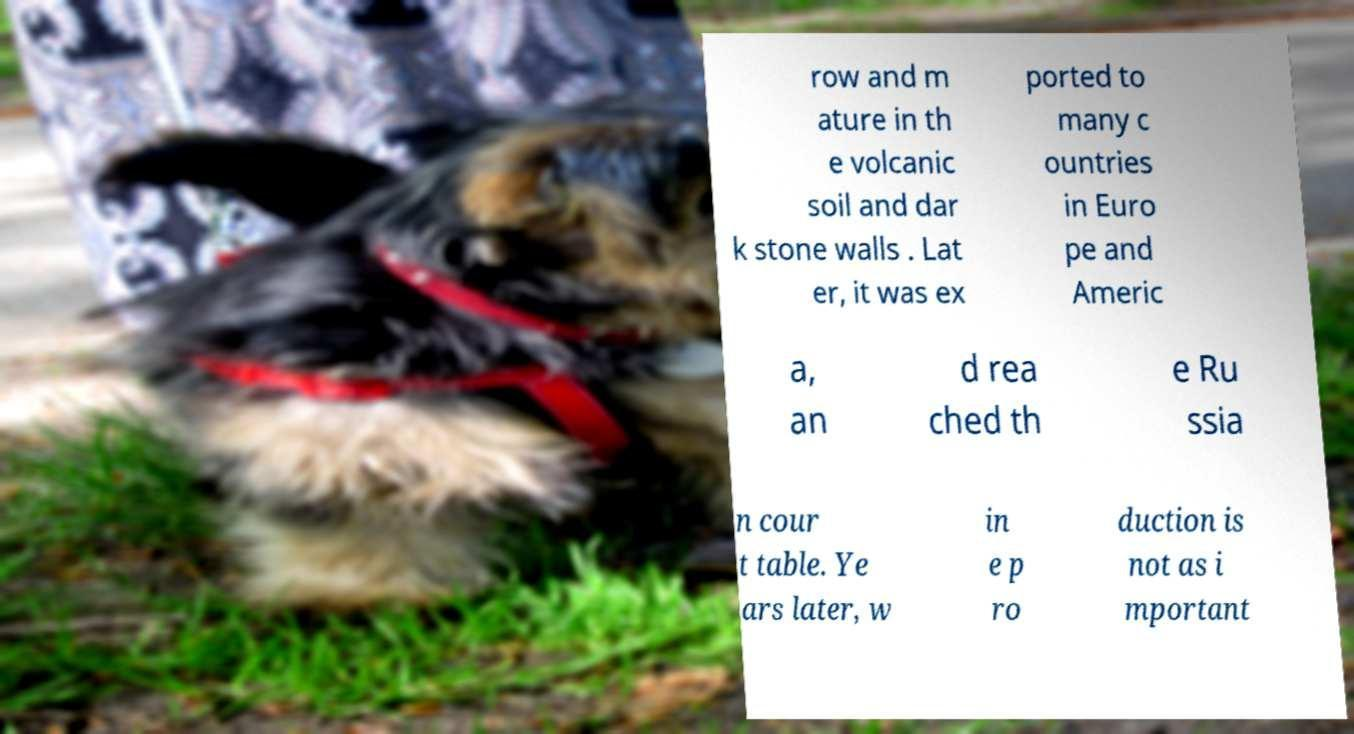I need the written content from this picture converted into text. Can you do that? row and m ature in th e volcanic soil and dar k stone walls . Lat er, it was ex ported to many c ountries in Euro pe and Americ a, an d rea ched th e Ru ssia n cour t table. Ye ars later, w in e p ro duction is not as i mportant 